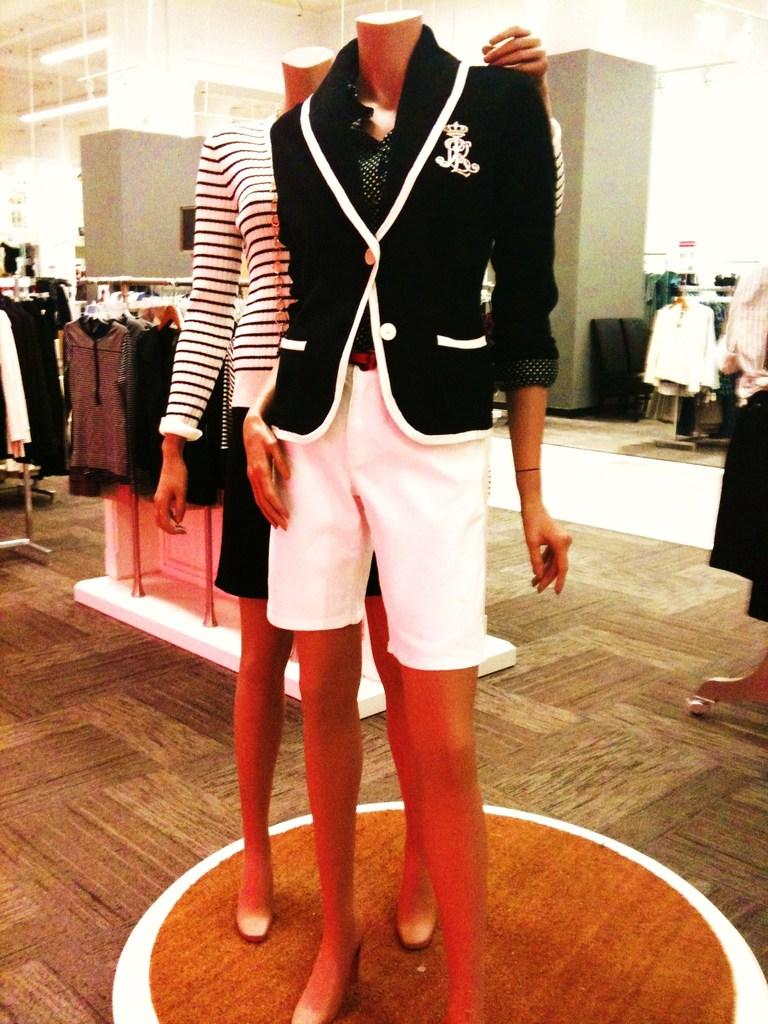What can be seen in the image? There are two statues in the image. What are the statues wearing? The statues are wearing clothes. What else can be seen in the image besides the statues? There are many other clothes on the left and right sides of the image. What is present on the ceiling in the image? There are lights attached to the ceiling in the image. How many spiders are crawling on the statues in the image? There are no spiders present in the image; the statues are wearing clothes and there are no spiders mentioned in the facts. What type of quiver is the statue holding in the image? There is no mention of a quiver or any weapon in the image; the statues are simply wearing clothes. 